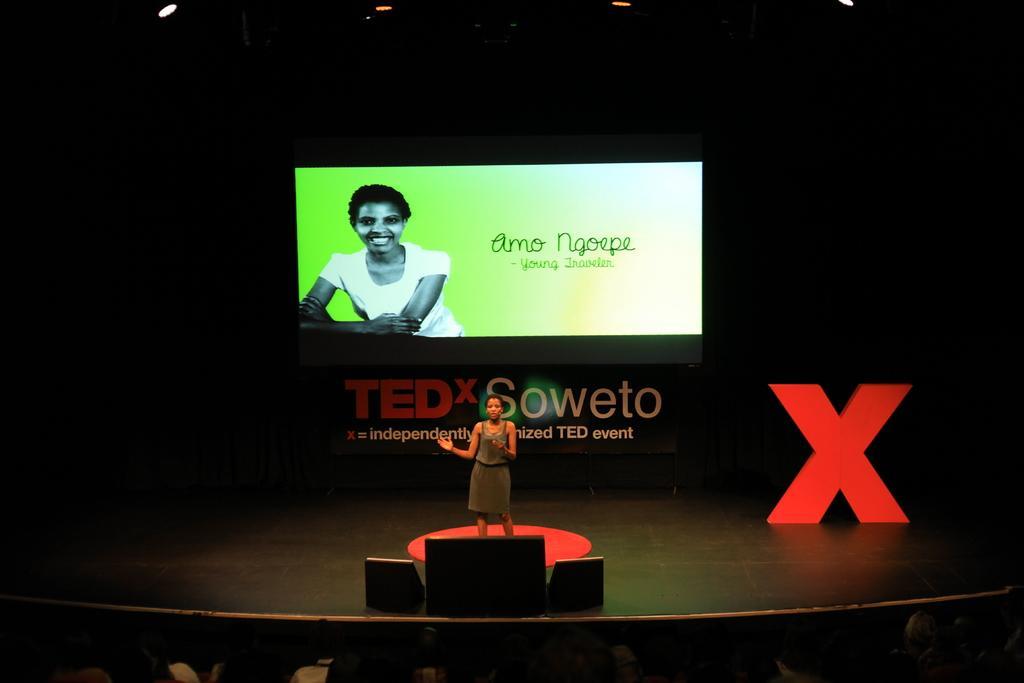How would you summarize this image in a sentence or two? In this image we can see one person standing on the stage, beside that we can see a few objects. And in the background we can see a screen with some text, beside that we can see text written on the board. And at the top we can see the lights. 